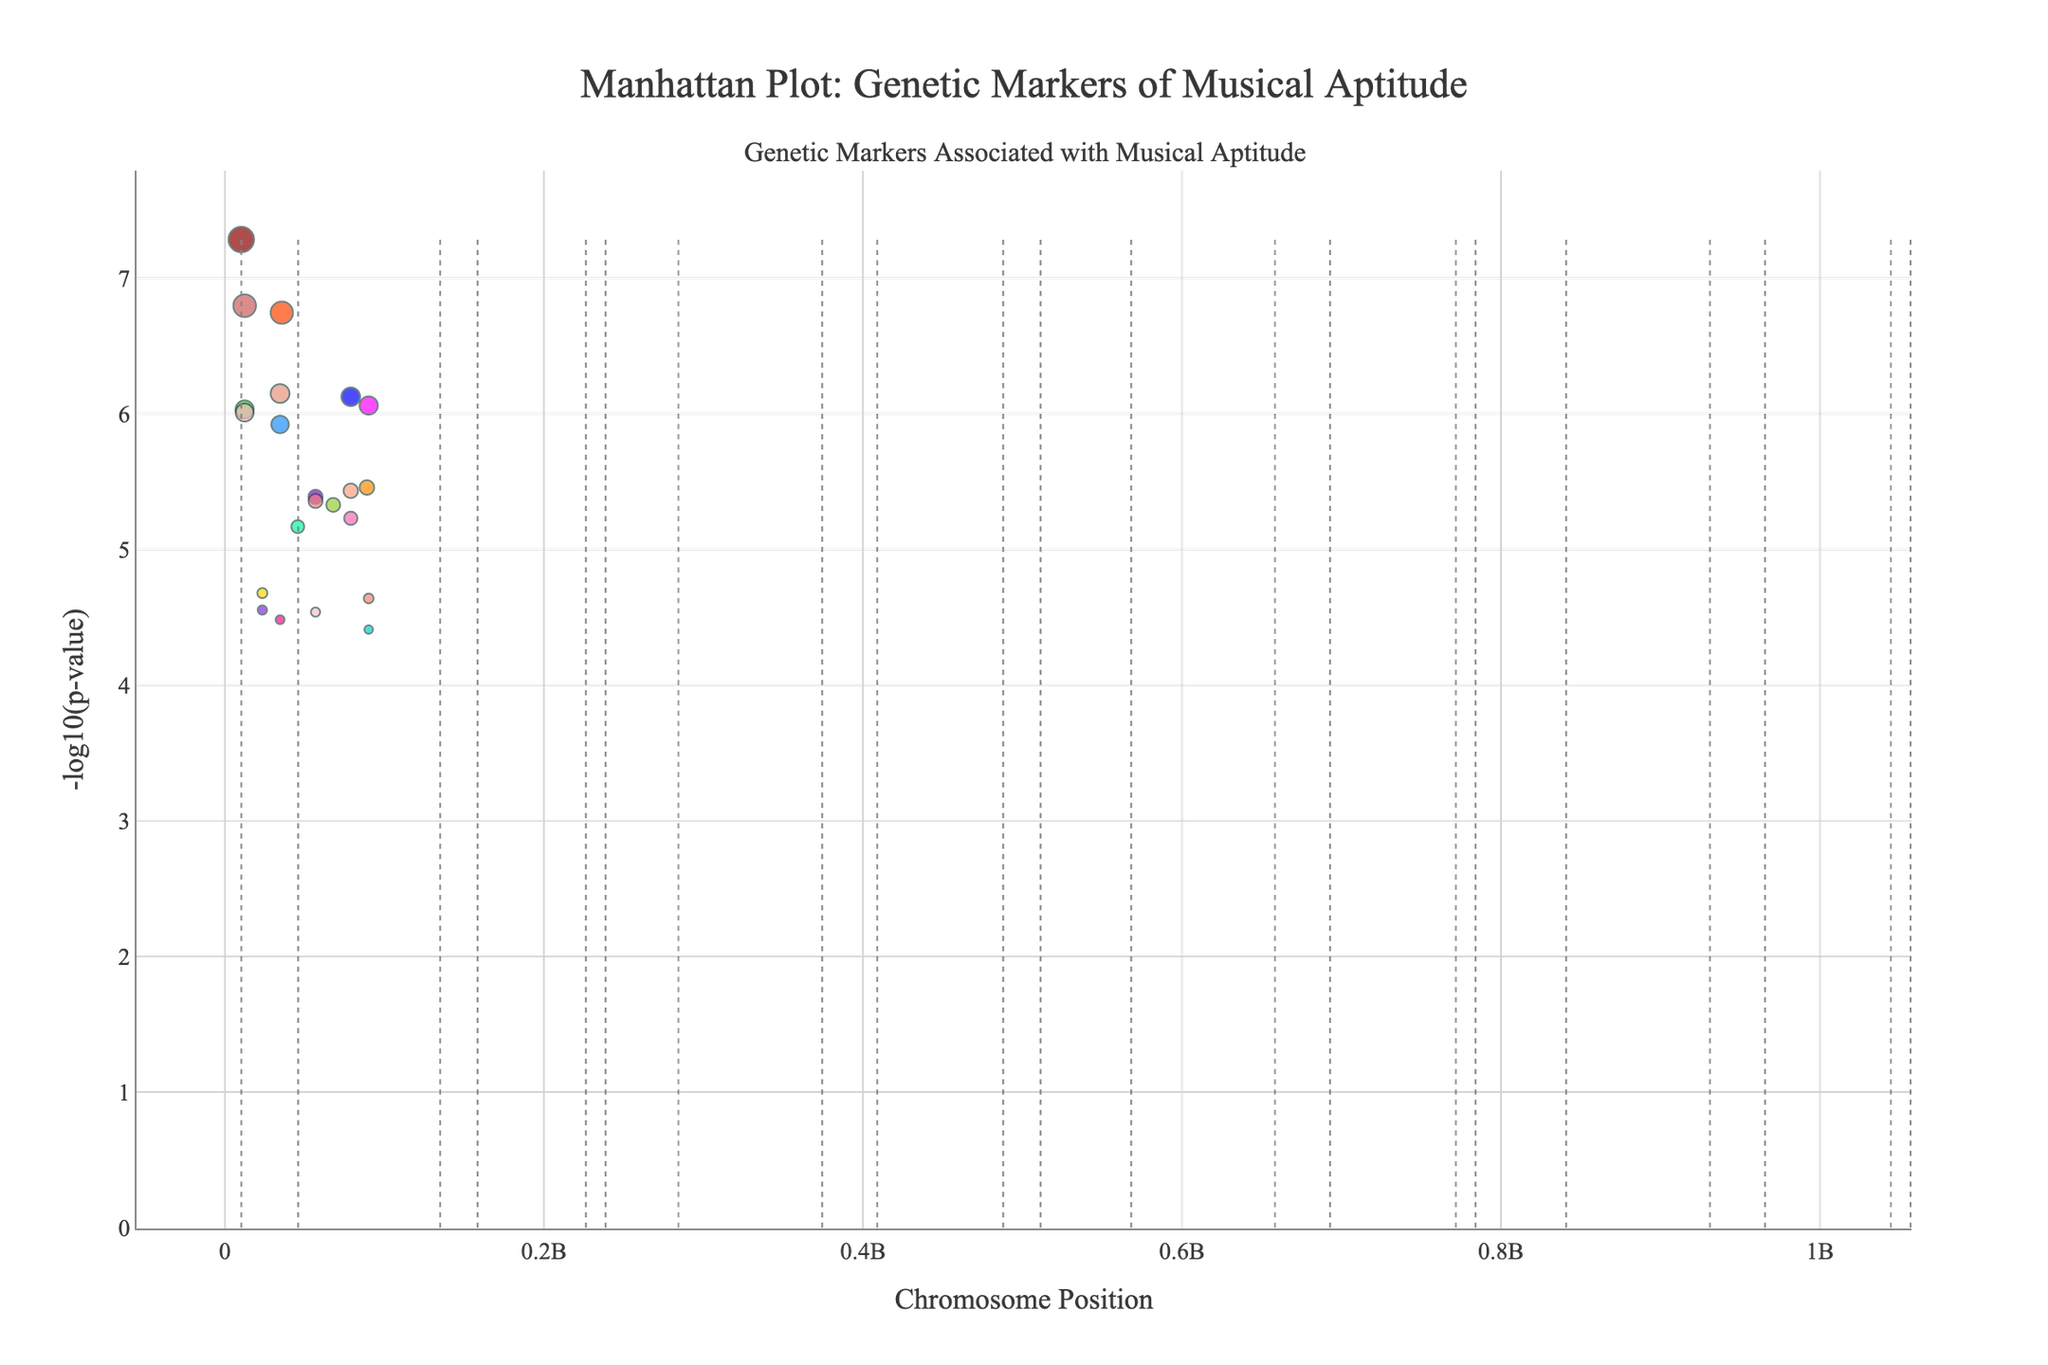Which gene shows the most significant p-value in the figure? Identify the point with the highest -log10(p_value) value. It corresponds to the most significant p-value. In this case, the gene FOXP2 on Chromosome 1 has the highest -log10(p_value) value, indicating the most significant p-value.
Answer: FOXP2 How is the significance of the genetic markers visually represented in this plot? The significance of each genetic marker is represented by the y-axis, which shows the -log10(p-value). The higher the point on the y-axis, the more significant the marker. The points are plotted based on their chromosome positions on the x-axis.
Answer: -log10(p-value) on the y-axis Which chromosome has the most genetic markers significantly associated with musical traits? Count the number of points for each chromosome. Chromosome 2 and Chromosome 12 have the highest number of significant markers.
Answer: Chromosome 2 & Chromosome 12 Is there a genetic marker associated with 'Absolute pitch' in the figure? If so, which gene is it? Look for the text labels or hover information corresponding to 'Absolute pitch'. The gene labeled "CACNA1C" on Chromosome 11 is associated with 'Absolute pitch'.
Answer: CACNA1C What's the highest -log10(p_value) represented in the plot, and what is its corresponding p-value? The highest -log10(p_value) is the peak on the plot. Using knowledge of logarithms, if the -log10(p_value) is 7, the corresponding p-value is 10^-7. The highest value in this dataset is -log10(5.2e-8), which is approximately 7.28.
Answer: 7.28 and 5.2e-8 Between 'Musical creativity' and 'Musical memory', which trait has a more significant associated genetic marker? Compare the -log10(p_value) of the points labeled 'Musical creativity' and 'Musical memory'. 'Musical creativity' (CNTNAP2 on Chromosome 6) has a higher -log10(p_value) than 'Musical memory' (AVPR1A on Chromosome 2).
Answer: Musical creativity How many genetic markers have a -log10(p_value) greater than 6? Count the points on the plot with y-values exceeding 6. There are 4 such markers: FOXP2, AVPR1A, CNTNAP2, and BDNF.
Answer: 4 Which chromosome has the widest range of positions for the associated genetic markers? Examine the x-axis range for each chromosome and identify the one with the largest span of positions for its markers. Chromosome 2 exhibits the widest range.
Answer: Chromosome 2 